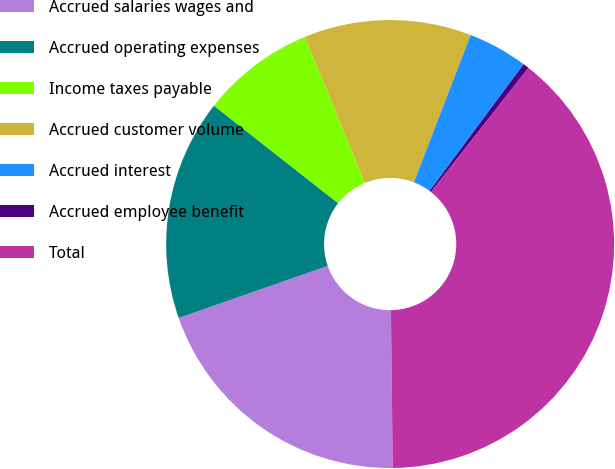Convert chart. <chart><loc_0><loc_0><loc_500><loc_500><pie_chart><fcel>Accrued salaries wages and<fcel>Accrued operating expenses<fcel>Income taxes payable<fcel>Accrued customer volume<fcel>Accrued interest<fcel>Accrued employee benefit<fcel>Total<nl><fcel>19.83%<fcel>15.95%<fcel>8.19%<fcel>12.07%<fcel>4.31%<fcel>0.43%<fcel>39.23%<nl></chart> 